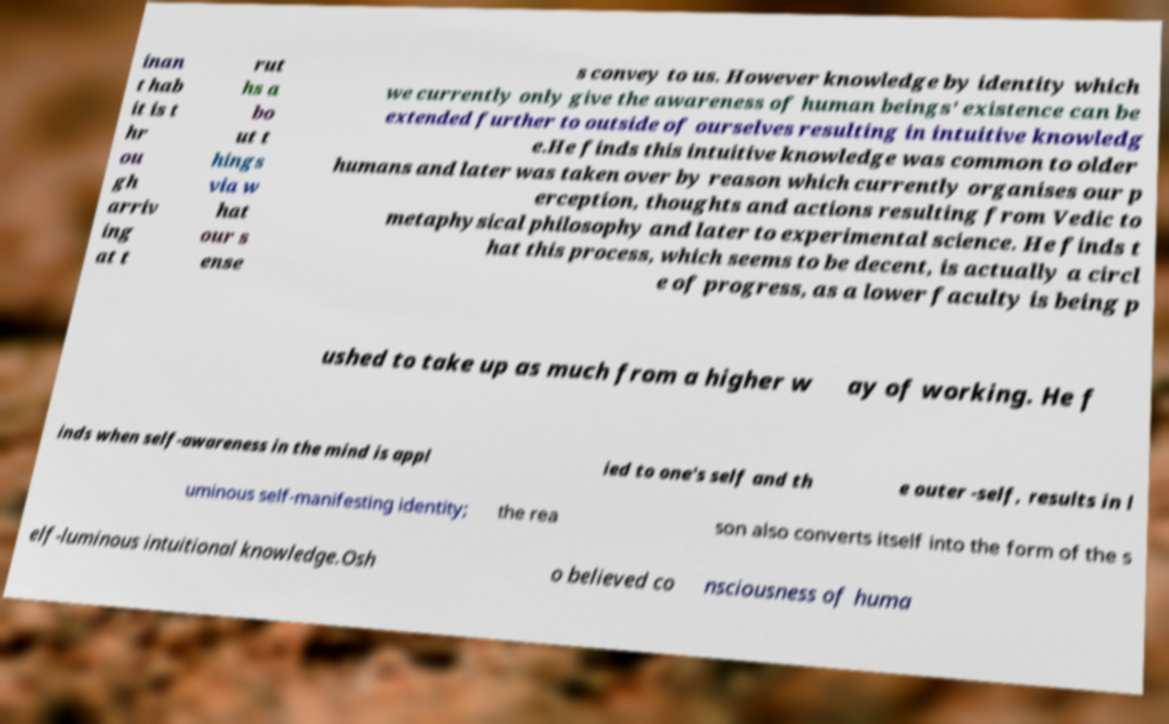Can you read and provide the text displayed in the image?This photo seems to have some interesting text. Can you extract and type it out for me? inan t hab it is t hr ou gh arriv ing at t rut hs a bo ut t hings via w hat our s ense s convey to us. However knowledge by identity which we currently only give the awareness of human beings' existence can be extended further to outside of ourselves resulting in intuitive knowledg e.He finds this intuitive knowledge was common to older humans and later was taken over by reason which currently organises our p erception, thoughts and actions resulting from Vedic to metaphysical philosophy and later to experimental science. He finds t hat this process, which seems to be decent, is actually a circl e of progress, as a lower faculty is being p ushed to take up as much from a higher w ay of working. He f inds when self-awareness in the mind is appl ied to one's self and th e outer -self, results in l uminous self-manifesting identity; the rea son also converts itself into the form of the s elf-luminous intuitional knowledge.Osh o believed co nsciousness of huma 